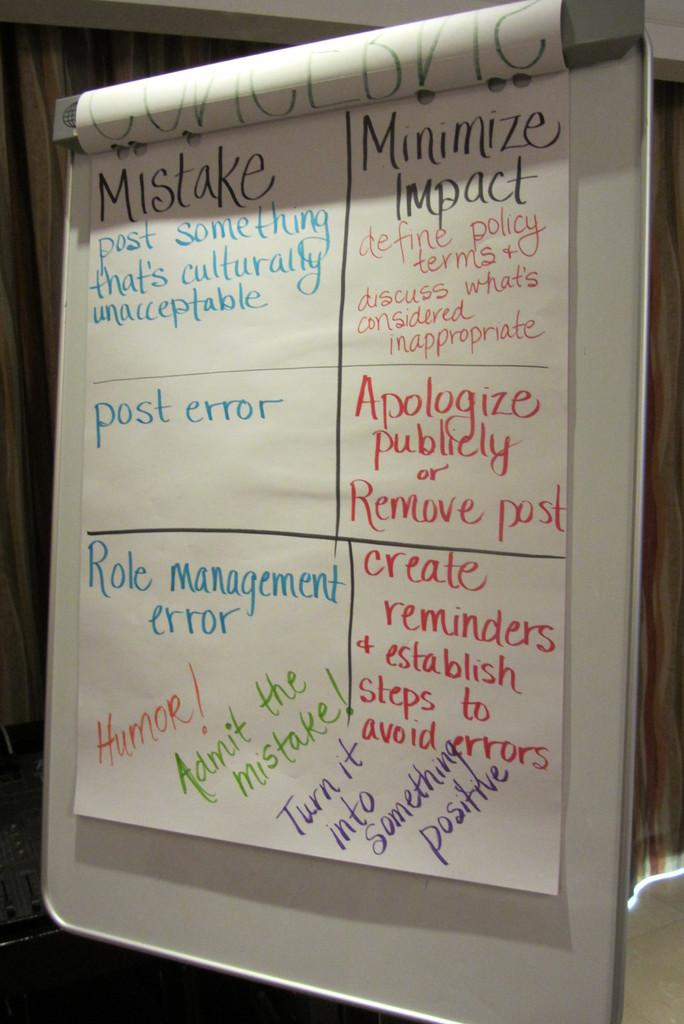<image>
Offer a succinct explanation of the picture presented. A large piece of paper is asking participants to post something culturally inappropriate. 